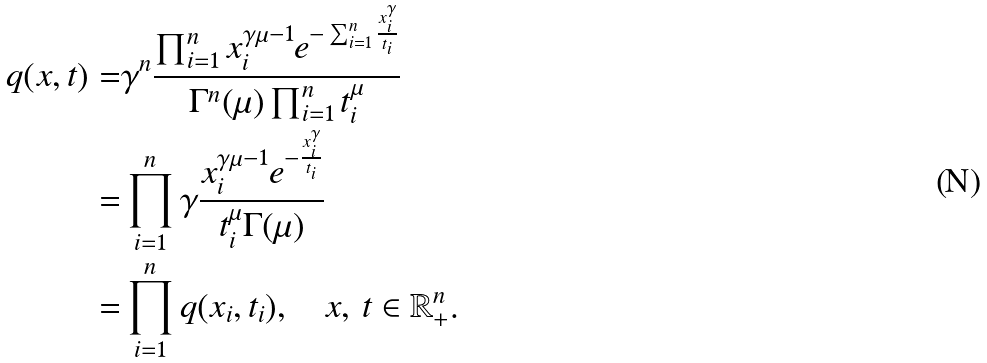Convert formula to latex. <formula><loc_0><loc_0><loc_500><loc_500>q ( x , t ) = & \gamma ^ { n } \frac { \prod _ { i = 1 } ^ { n } x _ { i } ^ { \gamma \mu - 1 } e ^ { - \sum _ { i = 1 } ^ { n } \frac { x _ { i } ^ { \gamma } } { t _ { i } } } } { \Gamma ^ { n } ( \mu ) \prod _ { i = 1 } ^ { n } t _ { i } ^ { \mu } } \\ = & \prod _ { i = 1 } ^ { n } \gamma \frac { x _ { i } ^ { \gamma \mu - 1 } e ^ { - \frac { x _ { i } ^ { \gamma } } { t _ { i } } } } { t _ { i } ^ { \mu } \Gamma ( \mu ) } \\ = & \prod _ { i = 1 } ^ { n } q ( x _ { i } , t _ { i } ) , \quad x , \, t \in \mathbb { R } ^ { n } _ { + } .</formula> 